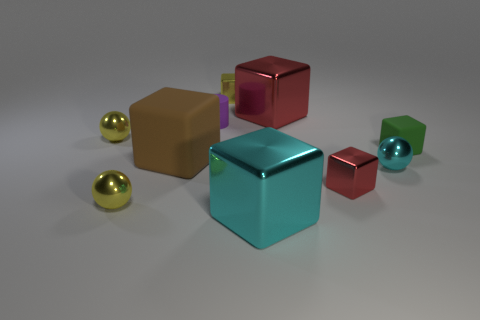Subtract all cyan spheres. How many red blocks are left? 2 Subtract all cyan metal balls. How many balls are left? 2 Subtract all red blocks. How many blocks are left? 4 Subtract all gray blocks. Subtract all cyan balls. How many blocks are left? 6 Subtract 0 blue balls. How many objects are left? 10 Subtract all balls. How many objects are left? 7 Subtract all shiny things. Subtract all small yellow objects. How many objects are left? 0 Add 1 small rubber cylinders. How many small rubber cylinders are left? 2 Add 4 tiny yellow metallic cubes. How many tiny yellow metallic cubes exist? 5 